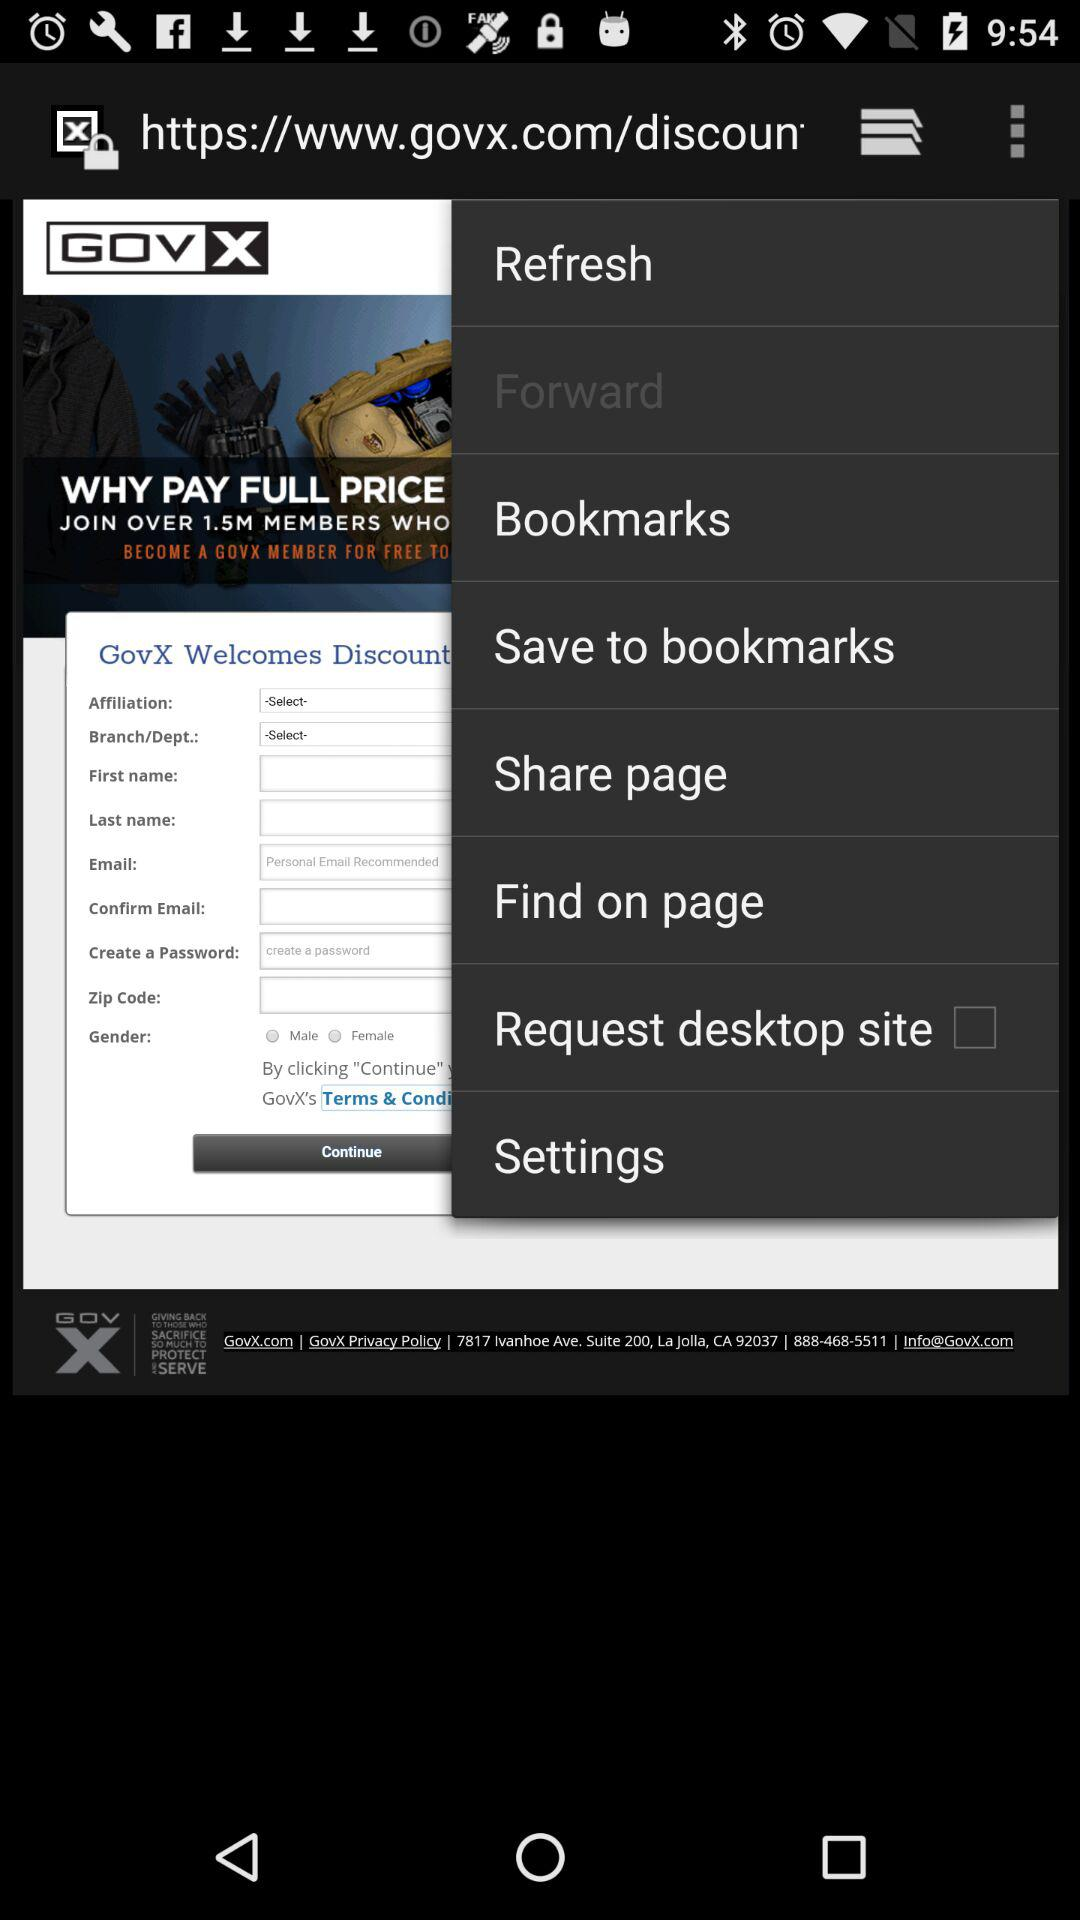What is the name of the application? The name of the application is "GovX". 